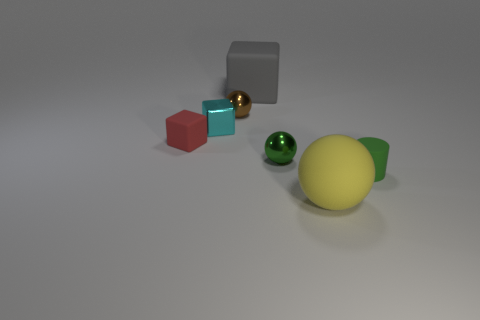Add 2 matte objects. How many objects exist? 9 Subtract all cylinders. How many objects are left? 6 Add 7 small brown balls. How many small brown balls are left? 8 Add 7 small blue metallic balls. How many small blue metallic balls exist? 7 Subtract 0 brown blocks. How many objects are left? 7 Subtract all tiny blocks. Subtract all blue metallic spheres. How many objects are left? 5 